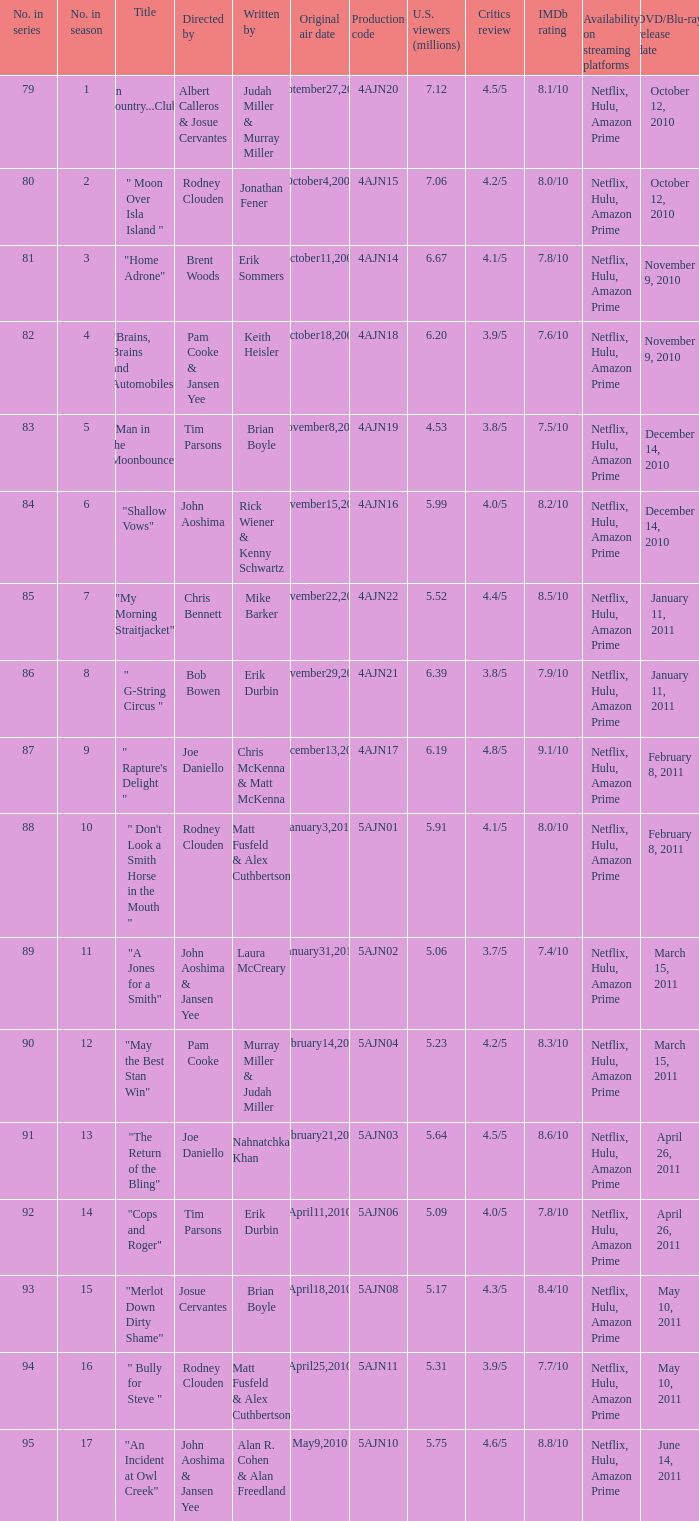Name who wrote the episode directed by  pam cooke & jansen yee Keith Heisler. Parse the full table. {'header': ['No. in series', 'No. in season', 'Title', 'Directed by', 'Written by', 'Original air date', 'Production code', 'U.S. viewers (millions)', 'Critics review', 'IMDb rating', 'Availability on streaming platforms', 'DVD/Blu-ray release date'], 'rows': [['79', '1', '"In Country...Club"', 'Albert Calleros & Josue Cervantes', 'Judah Miller & Murray Miller', 'September27,2009', '4AJN20', '7.12', '4.5/5', '8.1/10', 'Netflix, Hulu, Amazon Prime', 'October 12, 2010'], ['80', '2', '" Moon Over Isla Island "', 'Rodney Clouden', 'Jonathan Fener', 'October4,2009', '4AJN15', '7.06', '4.2/5', '8.0/10', 'Netflix, Hulu, Amazon Prime', 'October 12, 2010'], ['81', '3', '"Home Adrone"', 'Brent Woods', 'Erik Sommers', 'October11,2009', '4AJN14', '6.67', '4.1/5', '7.8/10', 'Netflix, Hulu, Amazon Prime', 'November 9, 2010'], ['82', '4', '"Brains, Brains and Automobiles"', 'Pam Cooke & Jansen Yee', 'Keith Heisler', 'October18,2009', '4AJN18', '6.20', '3.9/5', '7.6/10', 'Netflix, Hulu, Amazon Prime', 'November 9, 2010'], ['83', '5', '"Man in the Moonbounce"', 'Tim Parsons', 'Brian Boyle', 'November8,2009', '4AJN19', '4.53', '3.8/5', '7.5/10', 'Netflix, Hulu, Amazon Prime', 'December 14, 2010'], ['84', '6', '"Shallow Vows"', 'John Aoshima', 'Rick Wiener & Kenny Schwartz', 'November15,2009', '4AJN16', '5.99', '4.0/5', '8.2/10', 'Netflix, Hulu, Amazon Prime', 'December 14, 2010'], ['85', '7', '"My Morning Straitjacket"', 'Chris Bennett', 'Mike Barker', 'November22,2009', '4AJN22', '5.52', '4.4/5', '8.5/10', 'Netflix, Hulu, Amazon Prime', 'January 11, 2011'], ['86', '8', '" G-String Circus "', 'Bob Bowen', 'Erik Durbin', 'November29,2009', '4AJN21', '6.39', '3.8/5', '7.9/10', 'Netflix, Hulu, Amazon Prime', 'January 11, 2011'], ['87', '9', '" Rapture\'s Delight "', 'Joe Daniello', 'Chris McKenna & Matt McKenna', 'December13,2009', '4AJN17', '6.19', '4.8/5', '9.1/10', 'Netflix, Hulu, Amazon Prime', 'February 8, 2011'], ['88', '10', '" Don\'t Look a Smith Horse in the Mouth "', 'Rodney Clouden', 'Matt Fusfeld & Alex Cuthbertson', 'January3,2010', '5AJN01', '5.91', '4.1/5', '8.0/10', 'Netflix, Hulu, Amazon Prime', 'February 8, 2011'], ['89', '11', '"A Jones for a Smith"', 'John Aoshima & Jansen Yee', 'Laura McCreary', 'January31,2010', '5AJN02', '5.06', '3.7/5', '7.4/10', 'Netflix, Hulu, Amazon Prime', 'March 15, 2011'], ['90', '12', '"May the Best Stan Win"', 'Pam Cooke', 'Murray Miller & Judah Miller', 'February14,2010', '5AJN04', '5.23', '4.2/5', '8.3/10', 'Netflix, Hulu, Amazon Prime', 'March 15, 2011'], ['91', '13', '"The Return of the Bling"', 'Joe Daniello', 'Nahnatchka Khan', 'February21,2010', '5AJN03', '5.64', '4.5/5', '8.6/10', 'Netflix, Hulu, Amazon Prime', 'April 26, 2011'], ['92', '14', '"Cops and Roger"', 'Tim Parsons', 'Erik Durbin', 'April11,2010', '5AJN06', '5.09', '4.0/5', '7.8/10', 'Netflix, Hulu, Amazon Prime', 'April 26, 2011'], ['93', '15', '"Merlot Down Dirty Shame"', 'Josue Cervantes', 'Brian Boyle', 'April18,2010', '5AJN08', '5.17', '4.3/5', '8.4/10', 'Netflix, Hulu, Amazon Prime', 'May 10, 2011'], ['94', '16', '" Bully for Steve "', 'Rodney Clouden', 'Matt Fusfeld & Alex Cuthbertson', 'April25,2010', '5AJN11', '5.31', '3.9/5', '7.7/10', 'Netflix, Hulu, Amazon Prime', 'May 10, 2011'], ['95', '17', '"An Incident at Owl Creek"', 'John Aoshima & Jansen Yee', 'Alan R. Cohen & Alan Freedland', 'May9,2010', '5AJN10', '5.75', '4.6/5', '8.8/10', 'Netflix, Hulu, Amazon Prime', 'June 14, 2011']]} 